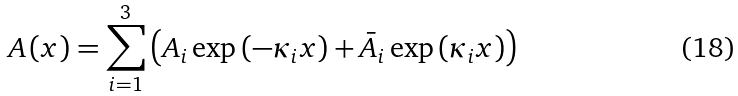<formula> <loc_0><loc_0><loc_500><loc_500>A \left ( x \right ) = \sum _ { i = 1 } ^ { 3 } \left ( A _ { i } \exp \left ( - \kappa _ { i } x \right ) + \bar { A } _ { i } \exp \left ( \kappa _ { i } x \right ) \right )</formula> 